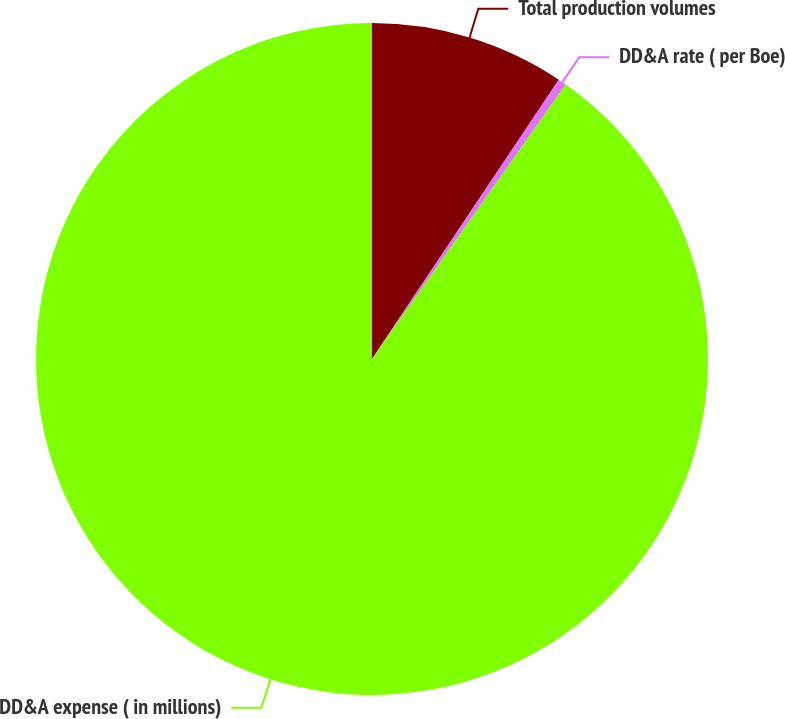<chart> <loc_0><loc_0><loc_500><loc_500><pie_chart><fcel>Total production volumes<fcel>DD&A rate ( per Boe)<fcel>DD&A expense ( in millions)<nl><fcel>9.38%<fcel>0.4%<fcel>90.21%<nl></chart> 